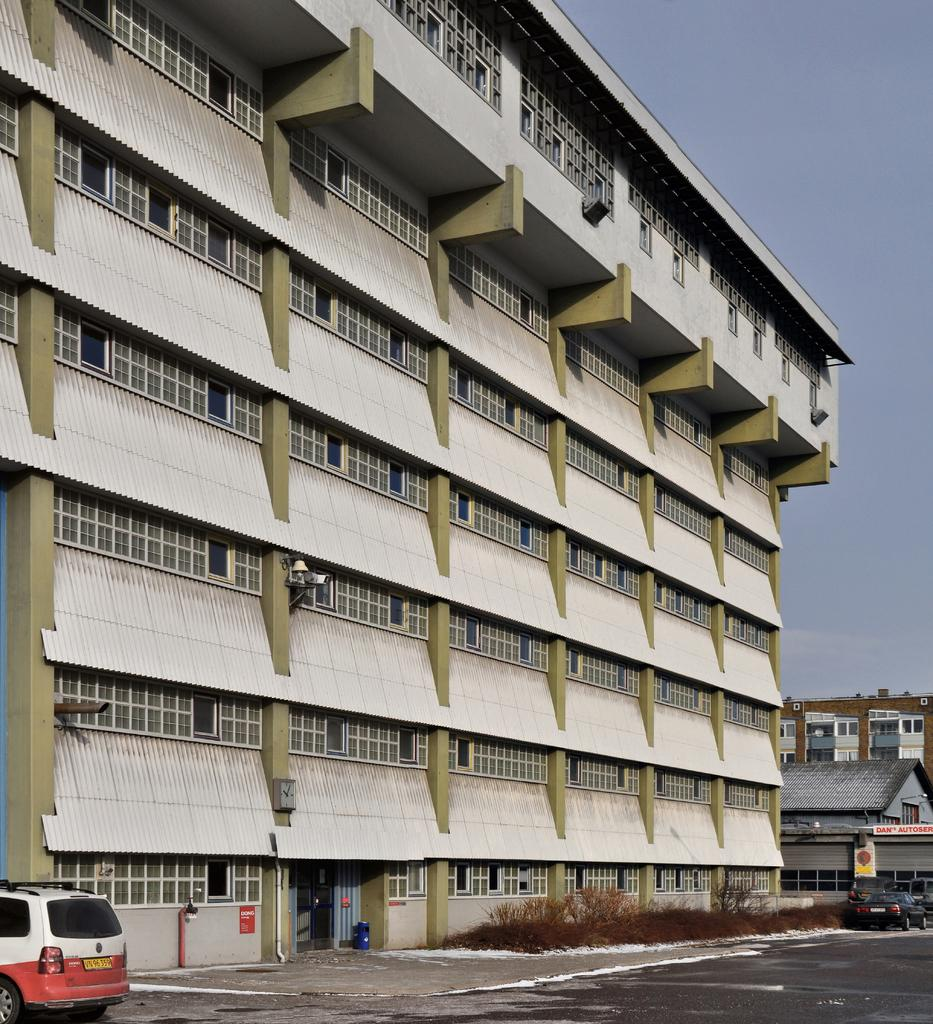What type of structures can be seen in the image? There are buildings in the image. What type of vehicles are present in the image? There are cars in the image. What type of vegetation is visible in the image? There are plants in the image. What is the color of the sky in the image? The sky is blue in the image. What type of print can be seen on the cars in the image? There is no specific print visible on the cars in the image; we can only see the general appearance of the cars. What type of discussion is taking place in the image? There is no discussion taking place in the image; it is a still image. 